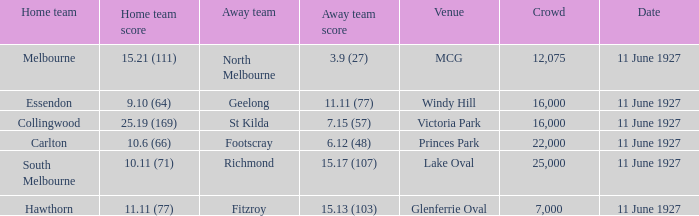What was the total number of people present in all the crowds at the mcg venue? 12075.0. 